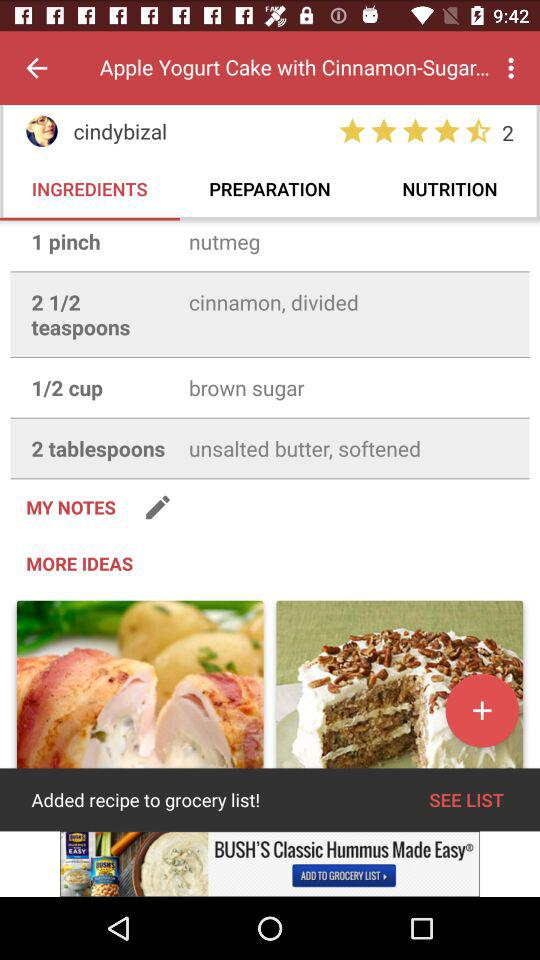What is the quantity of "brown sugar"? The quantity of "brown sugar" is half a cup. 